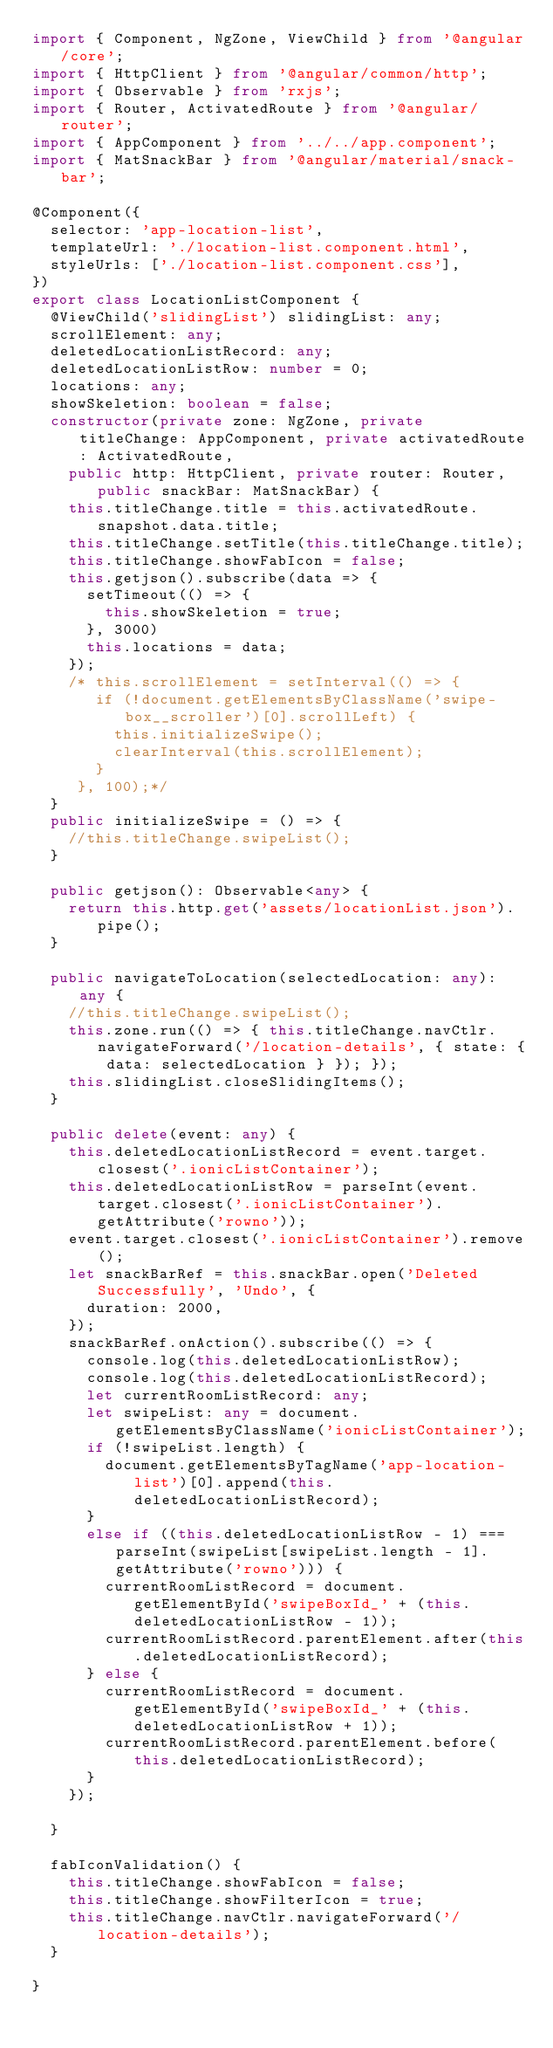Convert code to text. <code><loc_0><loc_0><loc_500><loc_500><_TypeScript_>import { Component, NgZone, ViewChild } from '@angular/core';
import { HttpClient } from '@angular/common/http';
import { Observable } from 'rxjs';
import { Router, ActivatedRoute } from '@angular/router';
import { AppComponent } from '../../app.component';
import { MatSnackBar } from '@angular/material/snack-bar';

@Component({
  selector: 'app-location-list',
  templateUrl: './location-list.component.html',
  styleUrls: ['./location-list.component.css'],
})
export class LocationListComponent {
  @ViewChild('slidingList') slidingList: any;
  scrollElement: any;
  deletedLocationListRecord: any;
  deletedLocationListRow: number = 0;
  locations: any;
  showSkeletion: boolean = false;
  constructor(private zone: NgZone, private titleChange: AppComponent, private activatedRoute: ActivatedRoute,
    public http: HttpClient, private router: Router, public snackBar: MatSnackBar) {
    this.titleChange.title = this.activatedRoute.snapshot.data.title;
    this.titleChange.setTitle(this.titleChange.title);
    this.titleChange.showFabIcon = false;
    this.getjson().subscribe(data => {
      setTimeout(() => {
        this.showSkeletion = true;
      }, 3000)
      this.locations = data;
    });
    /* this.scrollElement = setInterval(() => {
       if (!document.getElementsByClassName('swipe-box__scroller')[0].scrollLeft) {
         this.initializeSwipe();
         clearInterval(this.scrollElement);
       }
     }, 100);*/
  }
  public initializeSwipe = () => {
    //this.titleChange.swipeList();
  }

  public getjson(): Observable<any> {
    return this.http.get('assets/locationList.json').pipe();
  }

  public navigateToLocation(selectedLocation: any): any {
    //this.titleChange.swipeList();
    this.zone.run(() => { this.titleChange.navCtlr.navigateForward('/location-details', { state: { data: selectedLocation } }); });
    this.slidingList.closeSlidingItems();
  }

  public delete(event: any) {
    this.deletedLocationListRecord = event.target.closest('.ionicListContainer');
    this.deletedLocationListRow = parseInt(event.target.closest('.ionicListContainer').getAttribute('rowno'));
    event.target.closest('.ionicListContainer').remove();
    let snackBarRef = this.snackBar.open('Deleted Successfully', 'Undo', {
      duration: 2000,
    });
    snackBarRef.onAction().subscribe(() => {
      console.log(this.deletedLocationListRow);
      console.log(this.deletedLocationListRecord);
      let currentRoomListRecord: any;
      let swipeList: any = document.getElementsByClassName('ionicListContainer');
      if (!swipeList.length) {
        document.getElementsByTagName('app-location-list')[0].append(this.deletedLocationListRecord);
      }
      else if ((this.deletedLocationListRow - 1) === parseInt(swipeList[swipeList.length - 1].getAttribute('rowno'))) {
        currentRoomListRecord = document.getElementById('swipeBoxId_' + (this.deletedLocationListRow - 1));
        currentRoomListRecord.parentElement.after(this.deletedLocationListRecord);
      } else {
        currentRoomListRecord = document.getElementById('swipeBoxId_' + (this.deletedLocationListRow + 1));
        currentRoomListRecord.parentElement.before(this.deletedLocationListRecord);
      }
    });

  }

  fabIconValidation() {
    this.titleChange.showFabIcon = false;
    this.titleChange.showFilterIcon = true;
    this.titleChange.navCtlr.navigateForward('/location-details');
  }

}
</code> 